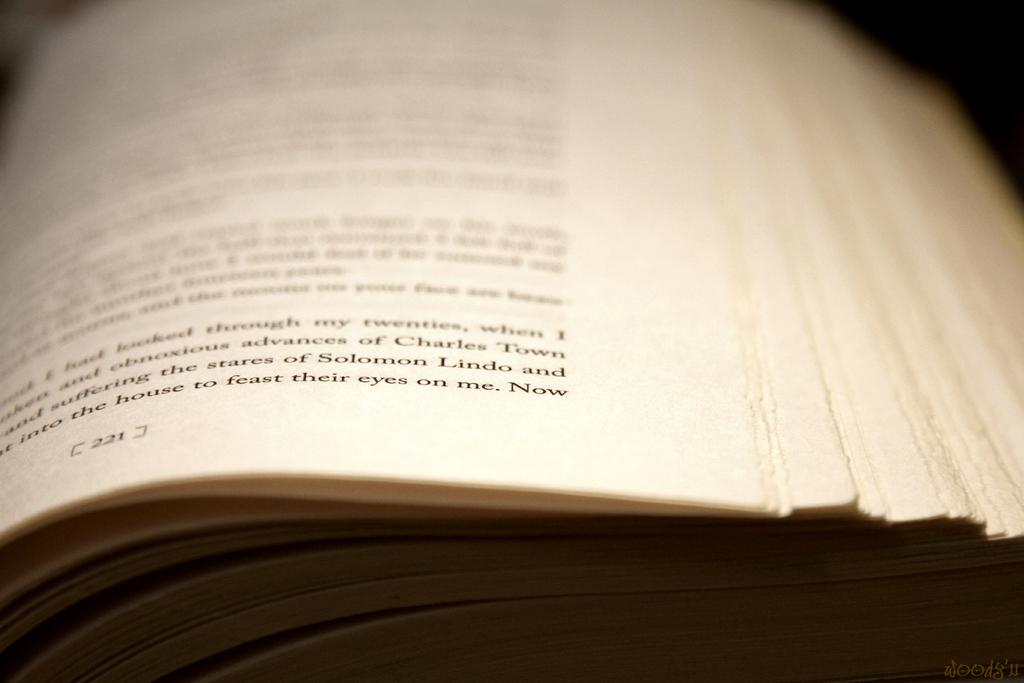<image>
Offer a succinct explanation of the picture presented. A book is opened to page 221 and the last word on the page is "now". 